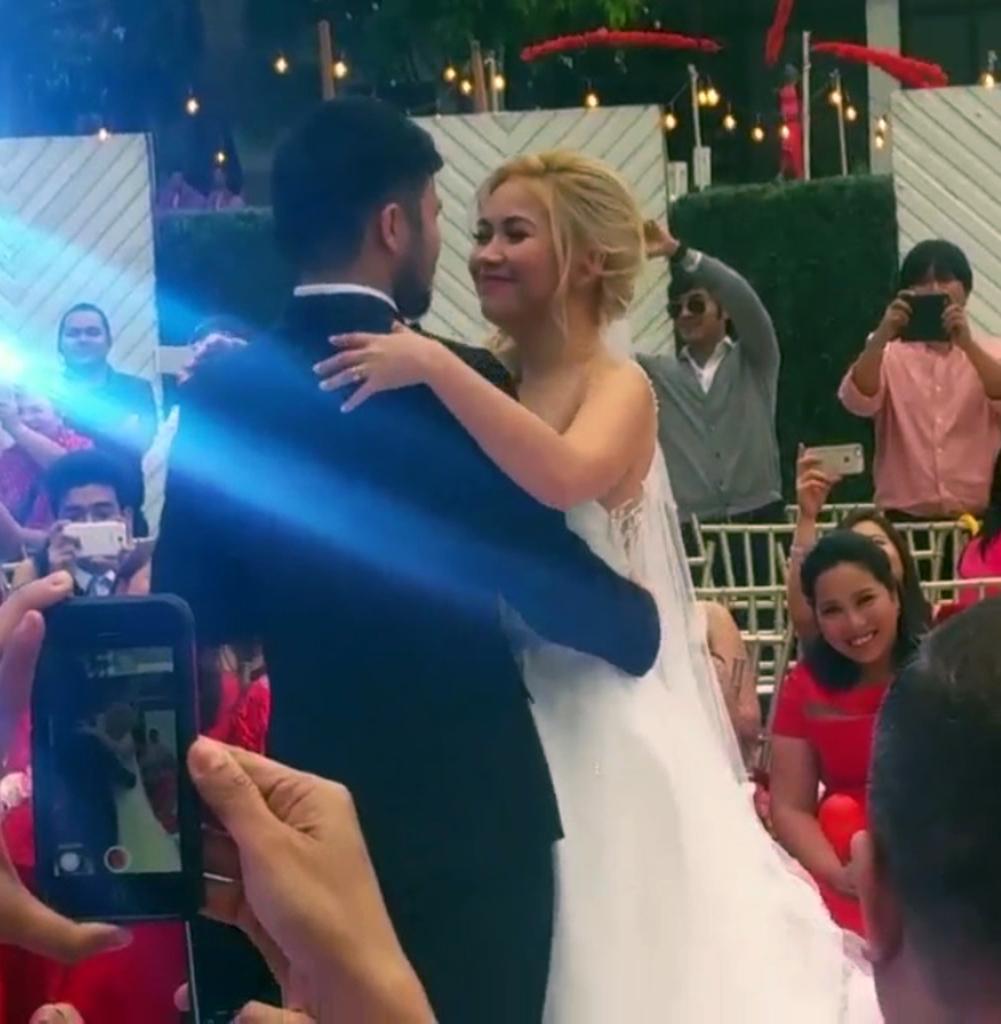Please provide a concise description of this image. This picture describes about group of people, few are seated and few are standing, and few people holding mobile phones, in the background we can see few lights, poles and trees. 